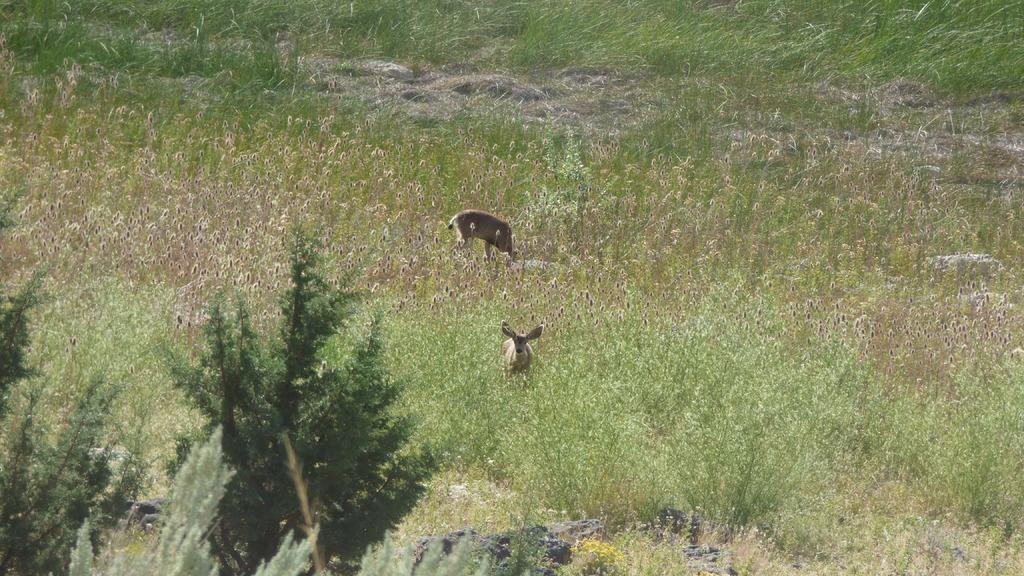What is the main feature of the landscape in the image? There is a lot of grass in the image. Can you describe any living creatures in the image? There are two animals in the grass. What type of vegetation is visible in the foreground of the image? There are trees in the foreground of the image. What type of pizzas are being served to the family in the image? There is no family or pizzas present in the image; it features grass and trees with two animals. 